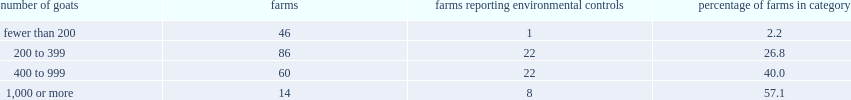What percentage of operator reporting 1000 goats or more said they used environmental controls? 57.1. 